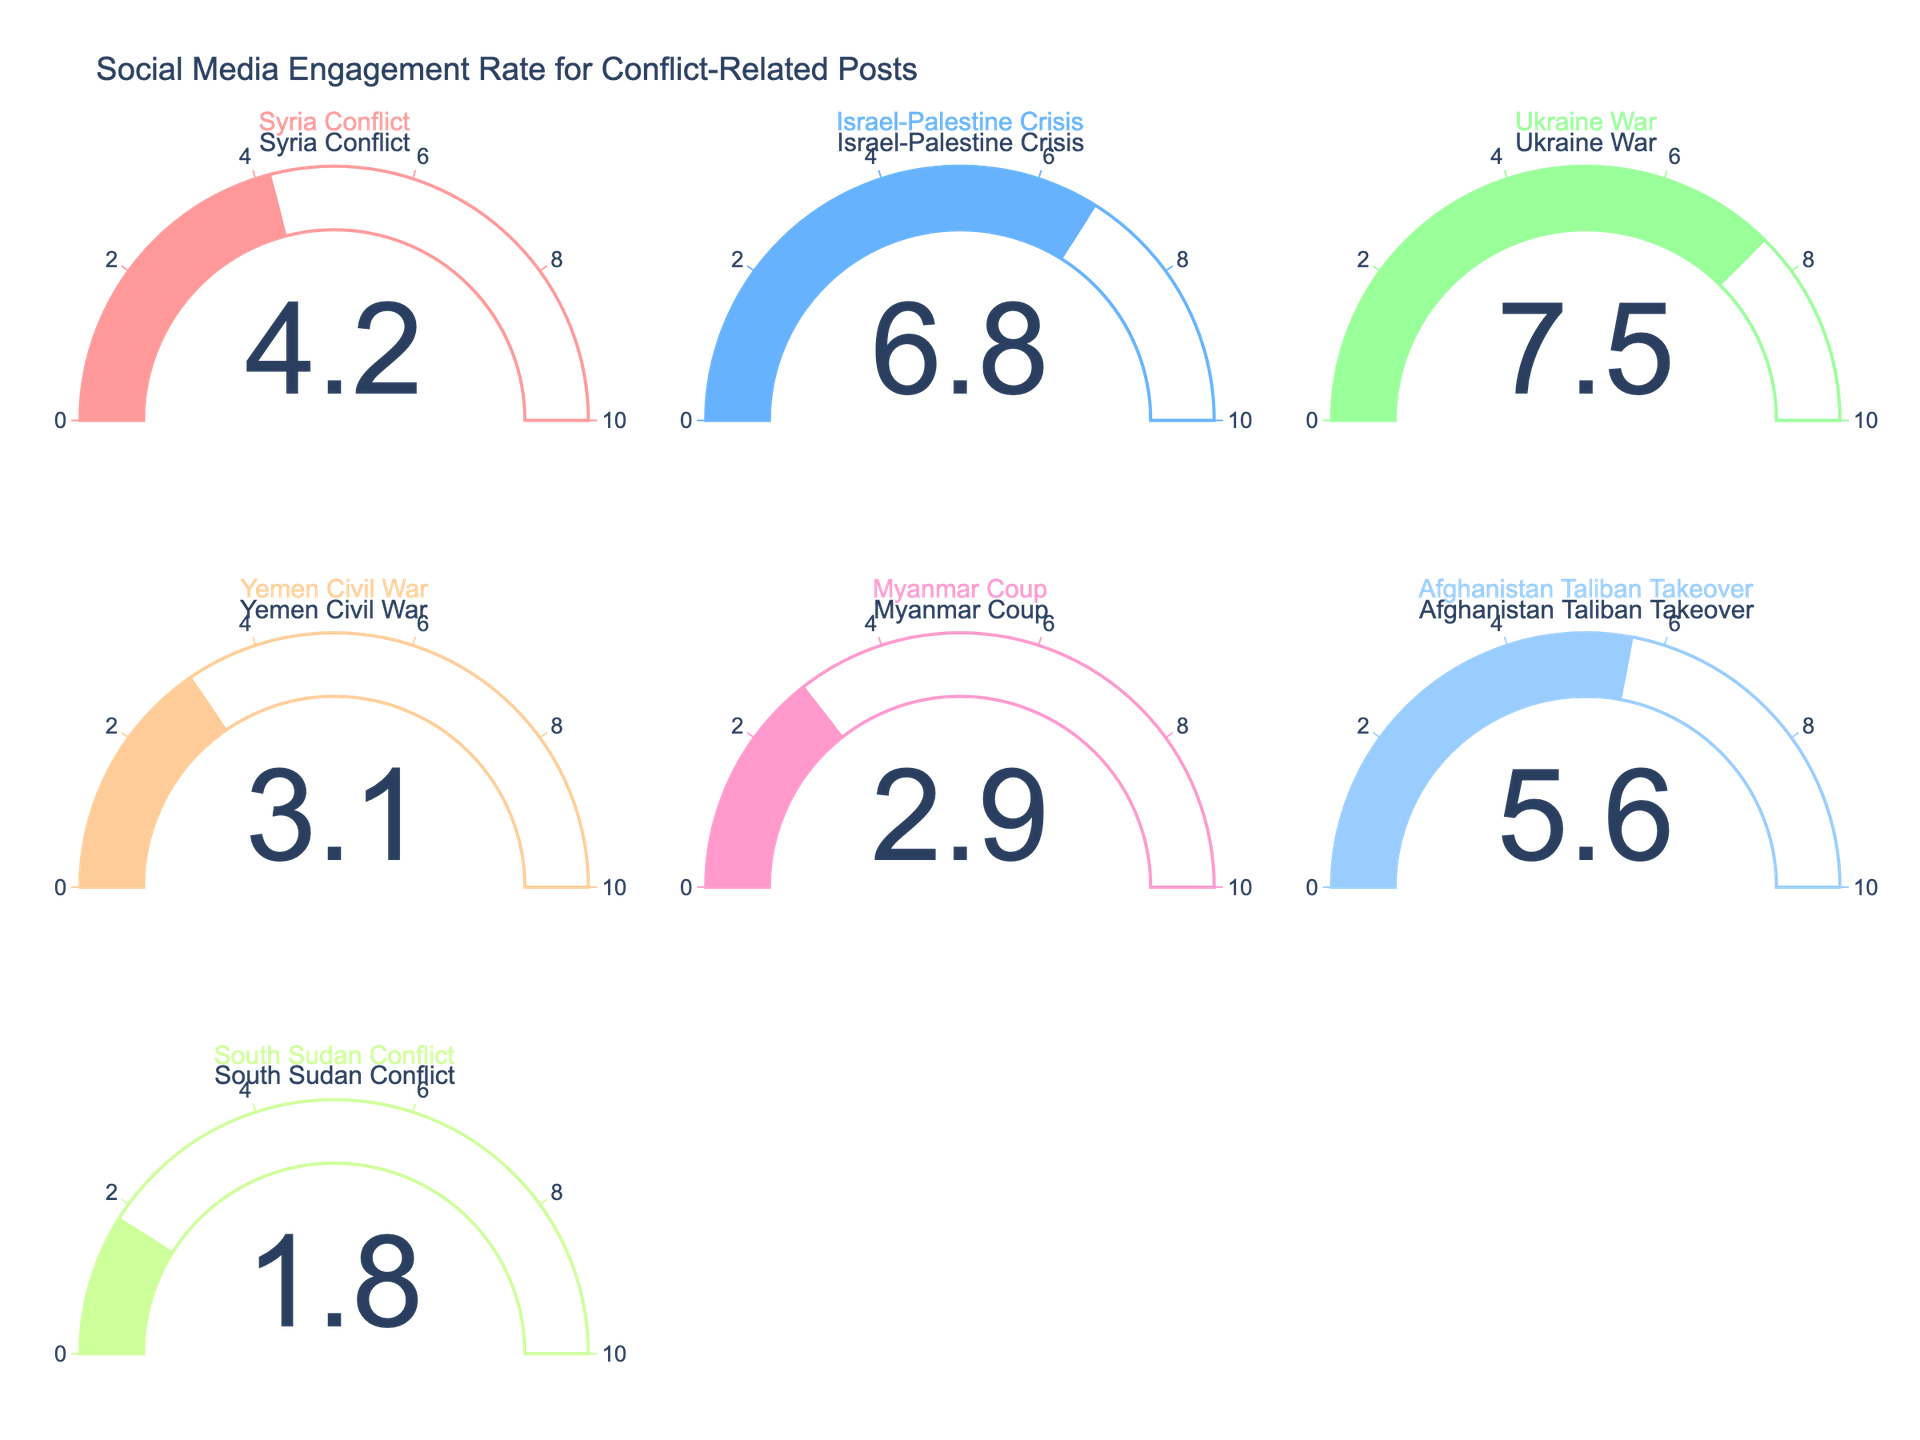What is the title of the figure? The title of the figure is typically found at the top and provides a quick summary of the content. It reads "Social Media Engagement Rate for Conflict-Related Posts" in this case.
Answer: Social Media Engagement Rate for Conflict-Related Posts Which conflict-related post has the highest engagement rate? To find the highest engagement rate, look at each gauge and note the value. The gauge for the Ukraine War shows the highest value at 7.5.
Answer: Ukraine War How many conflict topics are covered in the figure? Count the number of gauges in the subplot. Each gauge represents a different conflict topic. There are 7 gauges.
Answer: 7 What is the engagement rate for the Yemen Civil War? Locate the gauge labeled "Yemen Civil War" and check the value displayed. The engagement rate for the Yemen Civil War is 3.1.
Answer: 3.1 What is the combined engagement rate of the Syria Conflict and Afghanistan Taliban Takeover? Look at the values for these two conflicts: Syria Conflict (4.2) and Afghanistan Taliban Takeover (5.6). Add these numbers together (4.2 + 5.6) to get the combined rate.
Answer: 9.8 Which conflict has a lower engagement rate, Myanmar Coup or South Sudan Conflict? Compare the engagement rates shown on the gauges for Myanmar Coup (2.9) and South Sudan Conflict (1.8). The South Sudan Conflict has a lower engagement rate.
Answer: South Sudan Conflict What is the difference in engagement rate between the Israel-Palestine Crisis and the Yemen Civil War? Check the engagement rates: Israel-Palestine Crisis (6.8) and Yemen Civil War (3.1). Subtract the smaller number from the larger one (6.8 - 3.1).
Answer: 3.7 What is the average engagement rate of all the conflicts shown? Sum all the engagement rates (4.2 + 6.8 + 7.5 + 3.1 + 2.9 + 5.6 + 1.8) and divide by the number of conflicts (7). This gives (31.9) / 7.
Answer: 4.56 Is there any color pattern in the gauge indicators related to the engagement rate? Observe the colors used in the gauge indicators. Each gauge is filled with a unique color to differentiate them, but there is no specific pattern linking color to engagement rate values.
Answer: Unique colors, no specific pattern 